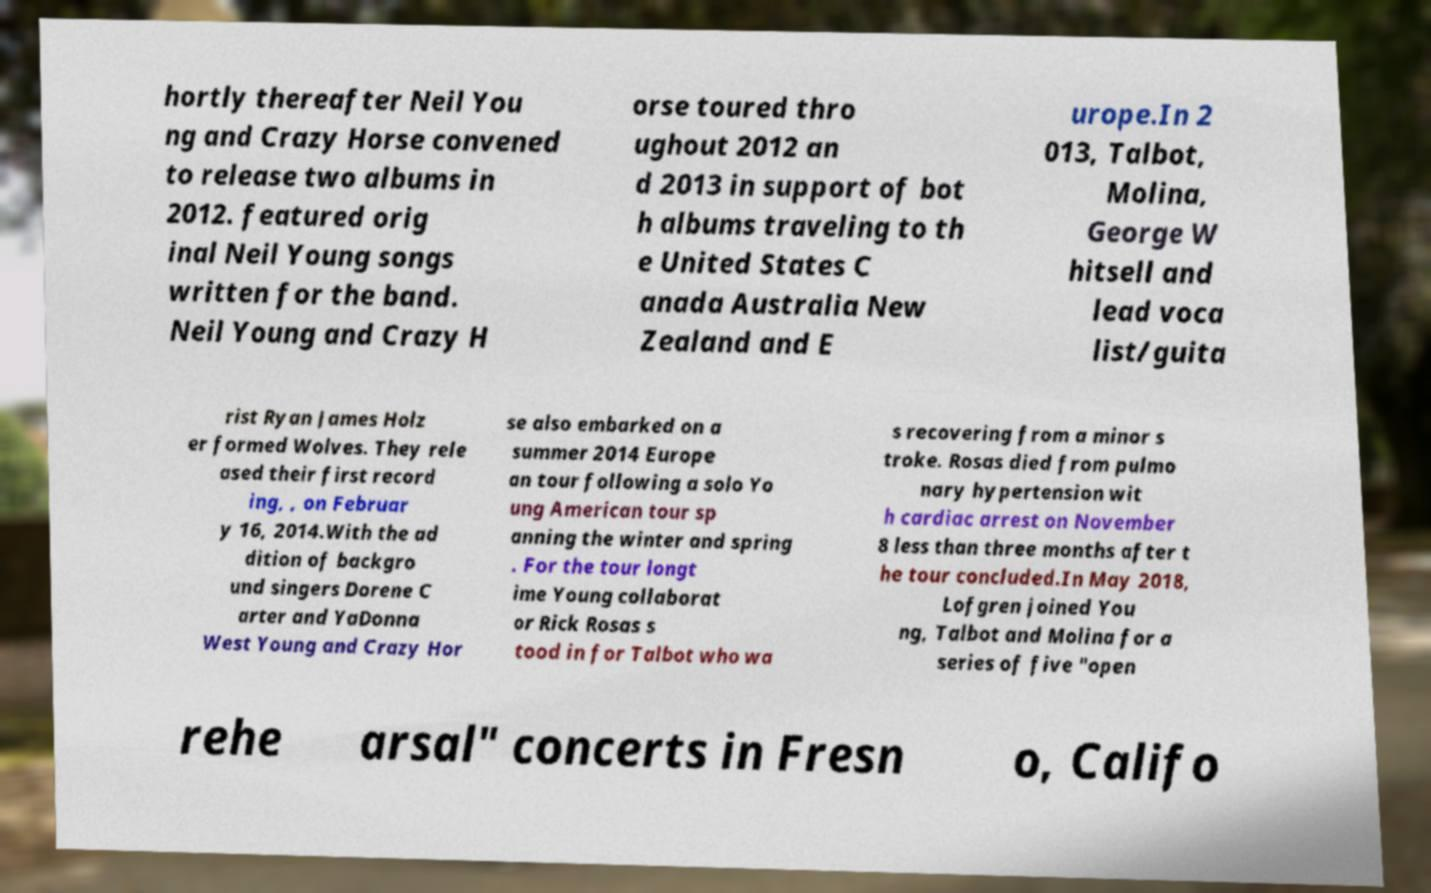Please read and relay the text visible in this image. What does it say? hortly thereafter Neil You ng and Crazy Horse convened to release two albums in 2012. featured orig inal Neil Young songs written for the band. Neil Young and Crazy H orse toured thro ughout 2012 an d 2013 in support of bot h albums traveling to th e United States C anada Australia New Zealand and E urope.In 2 013, Talbot, Molina, George W hitsell and lead voca list/guita rist Ryan James Holz er formed Wolves. They rele ased their first record ing, , on Februar y 16, 2014.With the ad dition of backgro und singers Dorene C arter and YaDonna West Young and Crazy Hor se also embarked on a summer 2014 Europe an tour following a solo Yo ung American tour sp anning the winter and spring . For the tour longt ime Young collaborat or Rick Rosas s tood in for Talbot who wa s recovering from a minor s troke. Rosas died from pulmo nary hypertension wit h cardiac arrest on November 8 less than three months after t he tour concluded.In May 2018, Lofgren joined You ng, Talbot and Molina for a series of five "open rehe arsal" concerts in Fresn o, Califo 